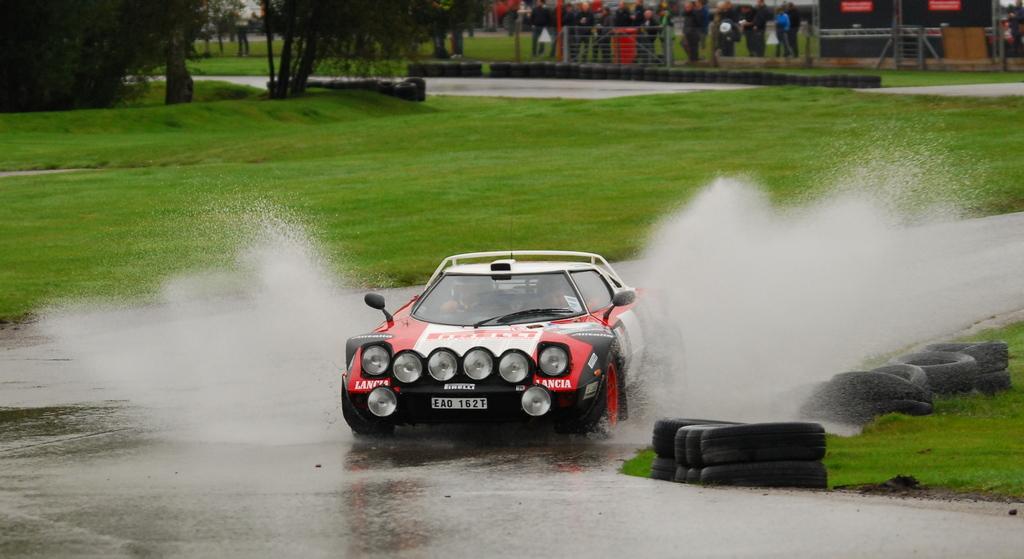In one or two sentences, can you explain what this image depicts? In this picture we can see one car raising of the road, beside the road we can see the grass. Back side, we can see one fencing few people are standing and watching. 